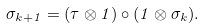<formula> <loc_0><loc_0><loc_500><loc_500>\sigma _ { k + 1 } = ( \tau \otimes 1 ) \circ ( 1 \otimes \sigma _ { k } ) .</formula> 